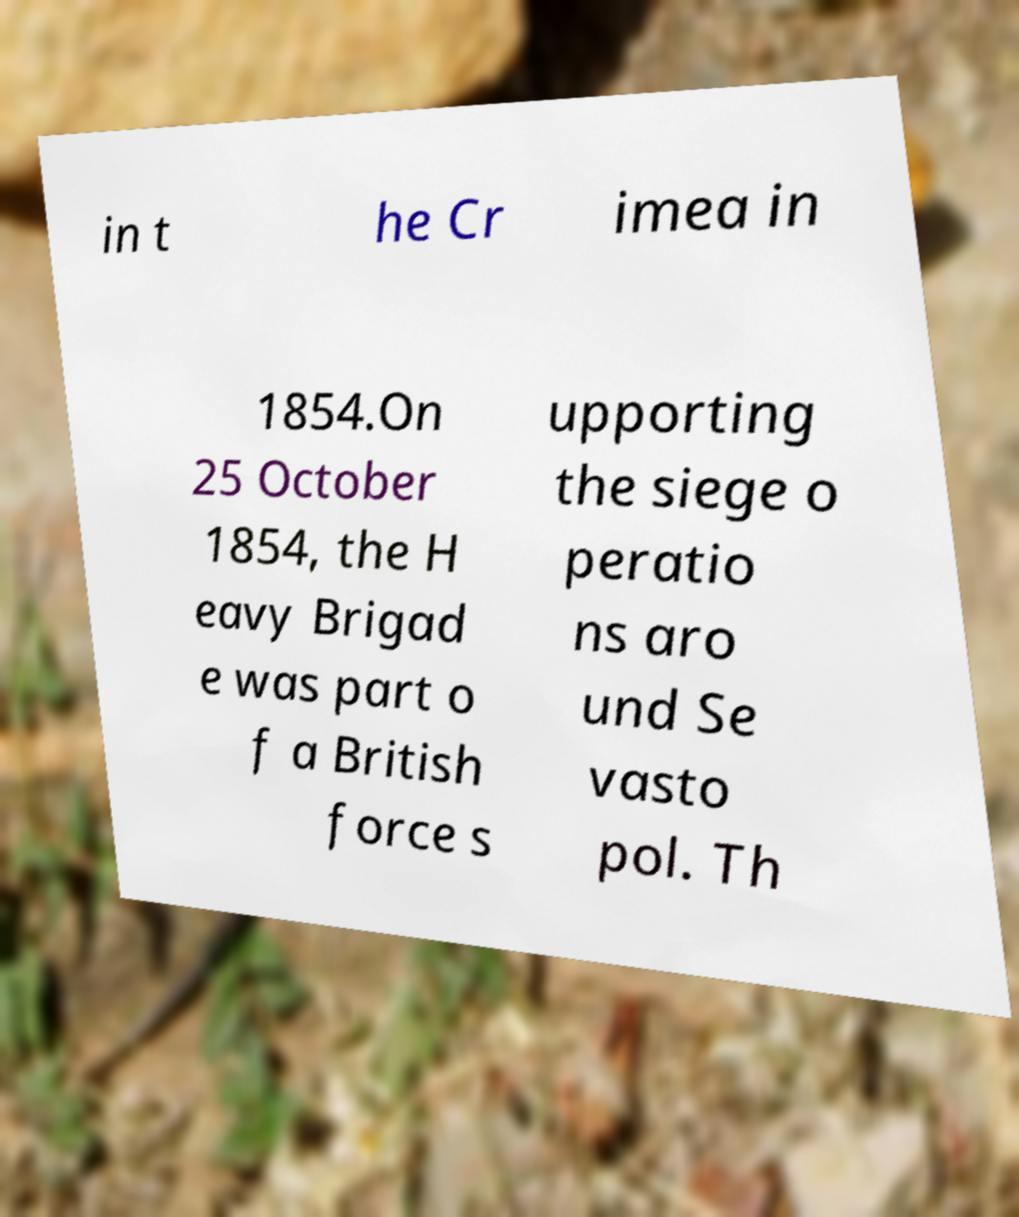Could you assist in decoding the text presented in this image and type it out clearly? in t he Cr imea in 1854.On 25 October 1854, the H eavy Brigad e was part o f a British force s upporting the siege o peratio ns aro und Se vasto pol. Th 